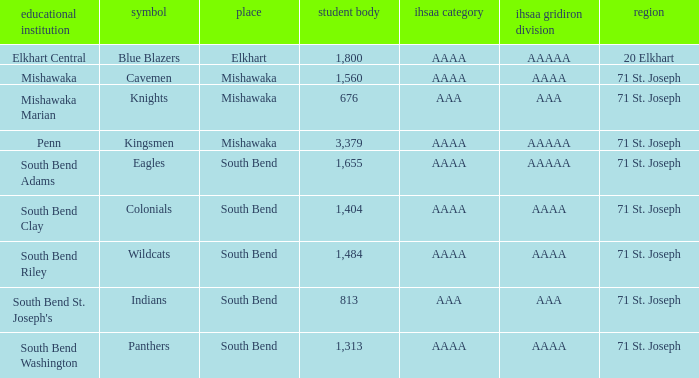What school has south bend as the location, with indians as the mascot? South Bend St. Joseph's. Could you parse the entire table? {'header': ['educational institution', 'symbol', 'place', 'student body', 'ihsaa category', 'ihsaa gridiron division', 'region'], 'rows': [['Elkhart Central', 'Blue Blazers', 'Elkhart', '1,800', 'AAAA', 'AAAAA', '20 Elkhart'], ['Mishawaka', 'Cavemen', 'Mishawaka', '1,560', 'AAAA', 'AAAA', '71 St. Joseph'], ['Mishawaka Marian', 'Knights', 'Mishawaka', '676', 'AAA', 'AAA', '71 St. Joseph'], ['Penn', 'Kingsmen', 'Mishawaka', '3,379', 'AAAA', 'AAAAA', '71 St. Joseph'], ['South Bend Adams', 'Eagles', 'South Bend', '1,655', 'AAAA', 'AAAAA', '71 St. Joseph'], ['South Bend Clay', 'Colonials', 'South Bend', '1,404', 'AAAA', 'AAAA', '71 St. Joseph'], ['South Bend Riley', 'Wildcats', 'South Bend', '1,484', 'AAAA', 'AAAA', '71 St. Joseph'], ["South Bend St. Joseph's", 'Indians', 'South Bend', '813', 'AAA', 'AAA', '71 St. Joseph'], ['South Bend Washington', 'Panthers', 'South Bend', '1,313', 'AAAA', 'AAAA', '71 St. Joseph']]} 